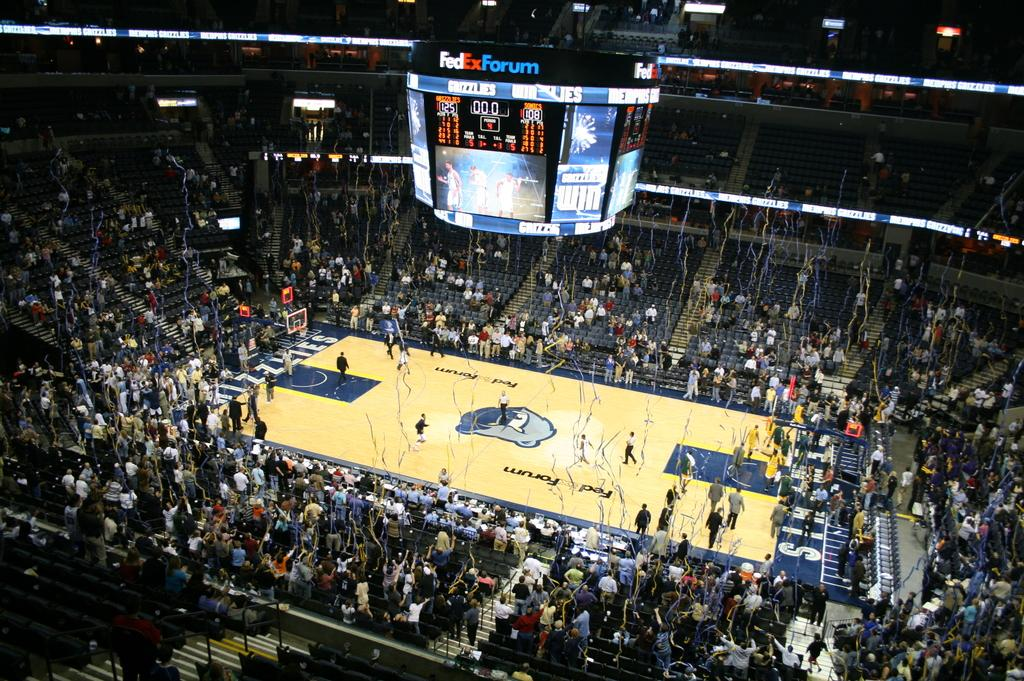Provide a one-sentence caption for the provided image. A scoreboard hanging from a stadium celing with the words Fedex Forum. 